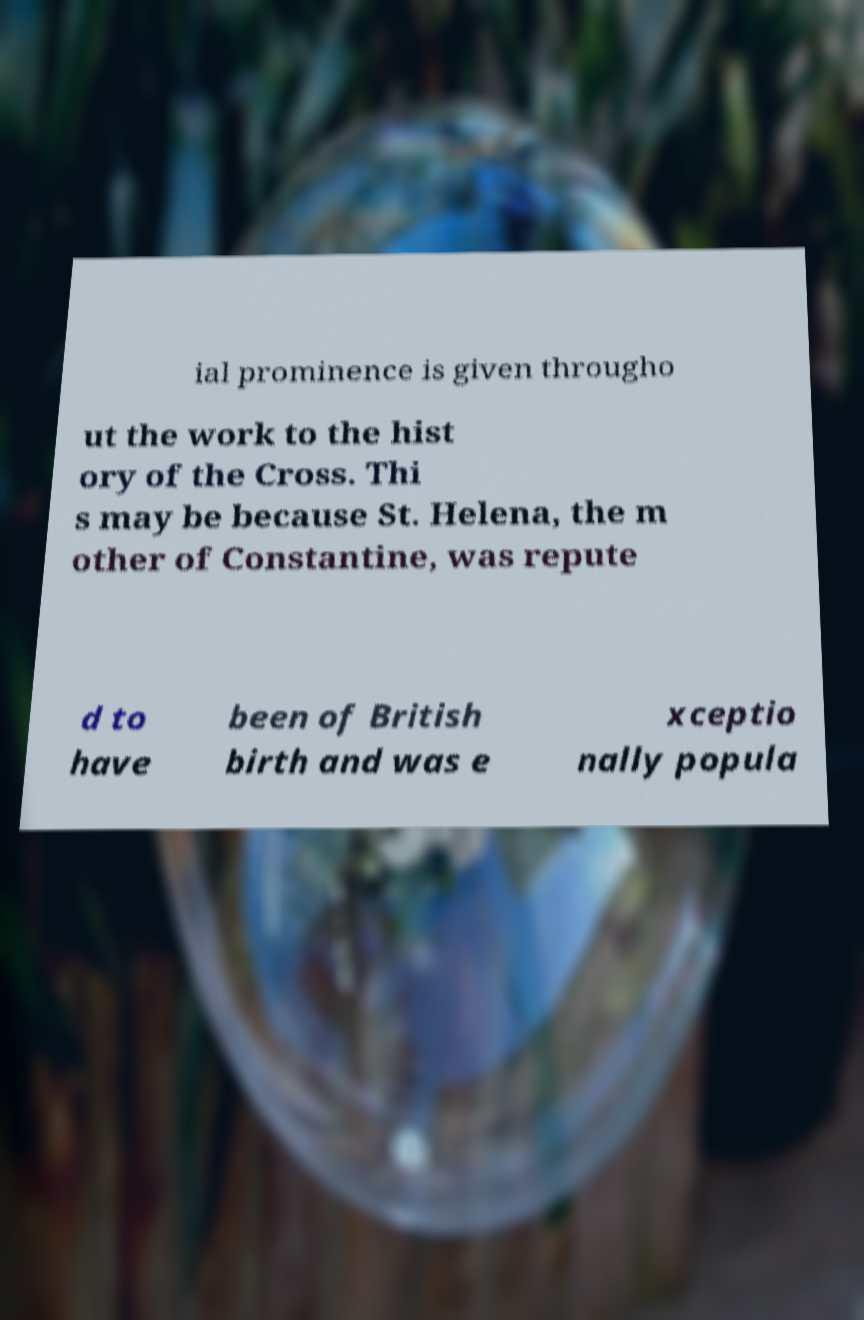Please identify and transcribe the text found in this image. ial prominence is given througho ut the work to the hist ory of the Cross. Thi s may be because St. Helena, the m other of Constantine, was repute d to have been of British birth and was e xceptio nally popula 